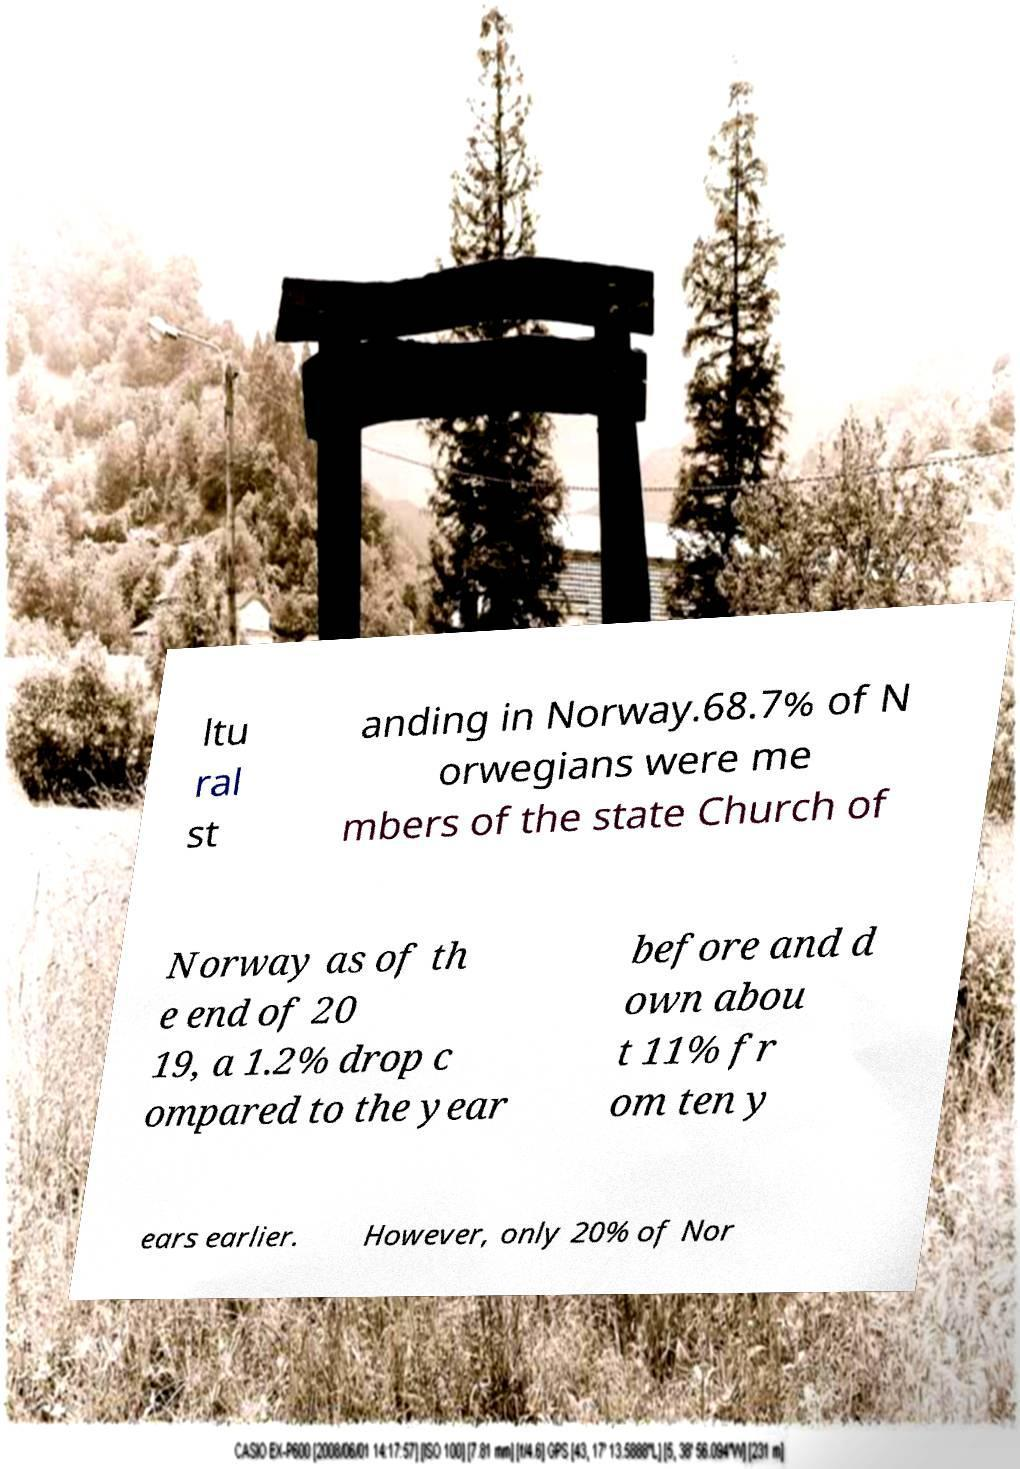Could you extract and type out the text from this image? ltu ral st anding in Norway.68.7% of N orwegians were me mbers of the state Church of Norway as of th e end of 20 19, a 1.2% drop c ompared to the year before and d own abou t 11% fr om ten y ears earlier. However, only 20% of Nor 